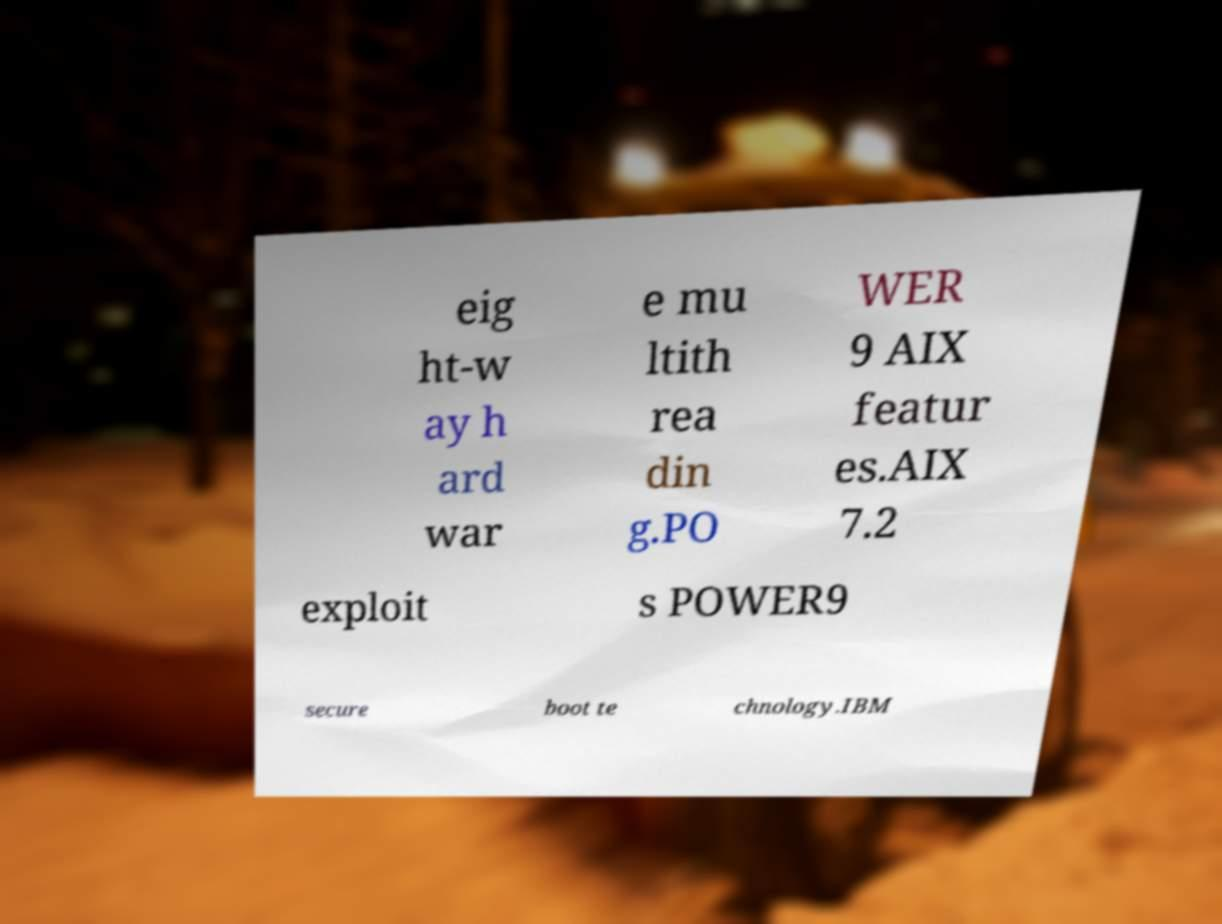What messages or text are displayed in this image? I need them in a readable, typed format. eig ht-w ay h ard war e mu ltith rea din g.PO WER 9 AIX featur es.AIX 7.2 exploit s POWER9 secure boot te chnology.IBM 